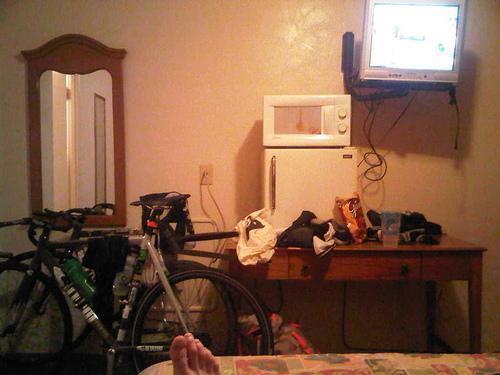How many tvs?
Give a very brief answer. 1. 